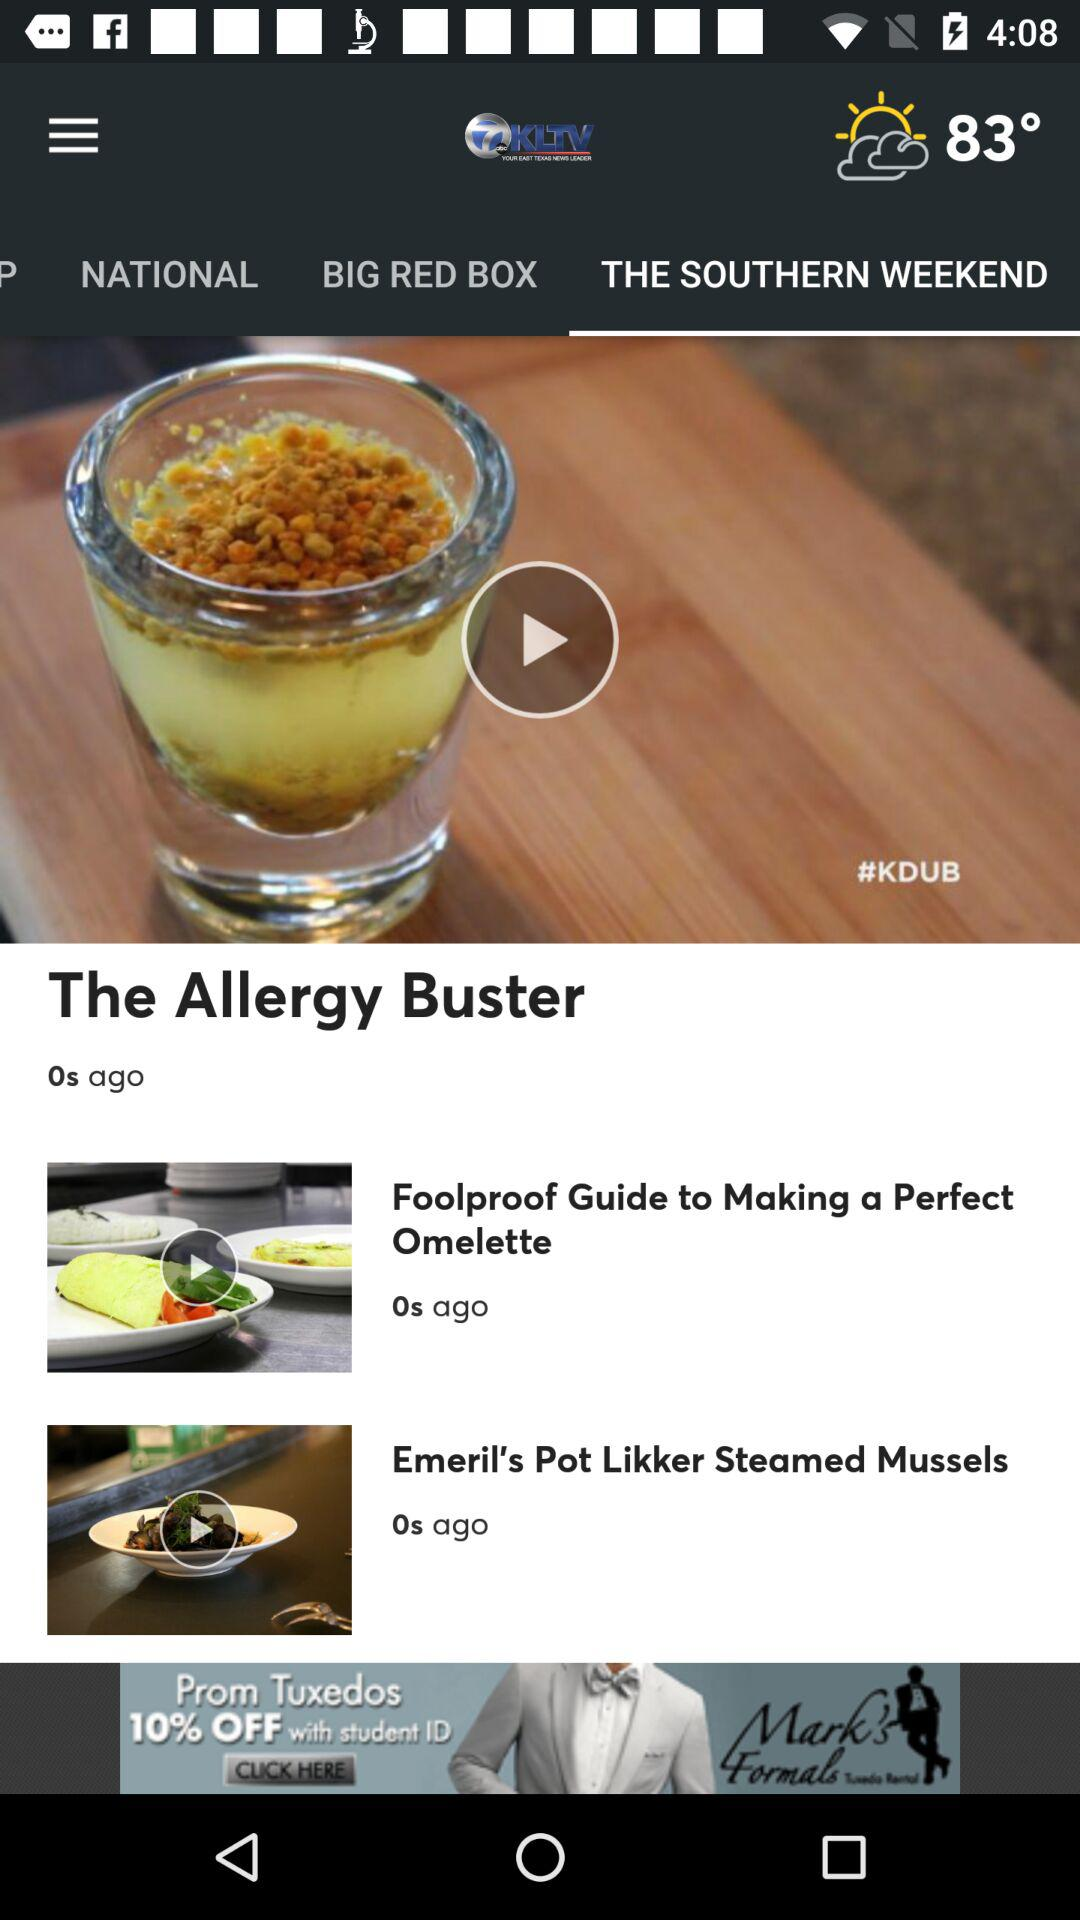How many articles are there in "NATIONAL"?
When the provided information is insufficient, respond with <no answer>. <no answer> 